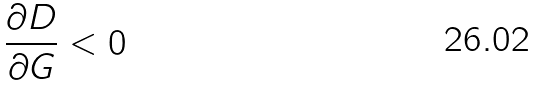Convert formula to latex. <formula><loc_0><loc_0><loc_500><loc_500>\frac { \partial D } { \partial G } < 0</formula> 